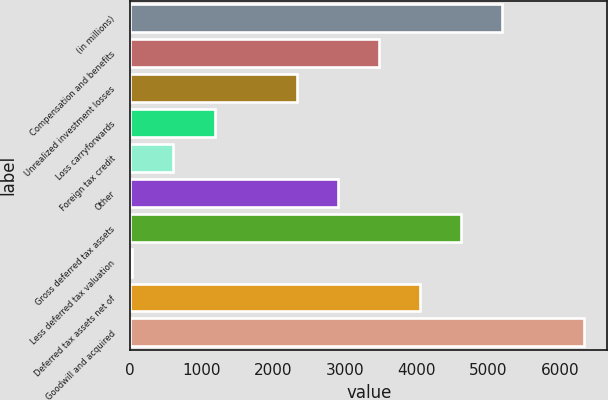Convert chart. <chart><loc_0><loc_0><loc_500><loc_500><bar_chart><fcel>(in millions)<fcel>Compensation and benefits<fcel>Unrealized investment losses<fcel>Loss carryforwards<fcel>Foreign tax credit<fcel>Other<fcel>Gross deferred tax assets<fcel>Less deferred tax valuation<fcel>Deferred tax assets net of<fcel>Goodwill and acquired<nl><fcel>5195.9<fcel>3473.6<fcel>2325.4<fcel>1177.2<fcel>603.1<fcel>2899.5<fcel>4621.8<fcel>29<fcel>4047.7<fcel>6344.1<nl></chart> 